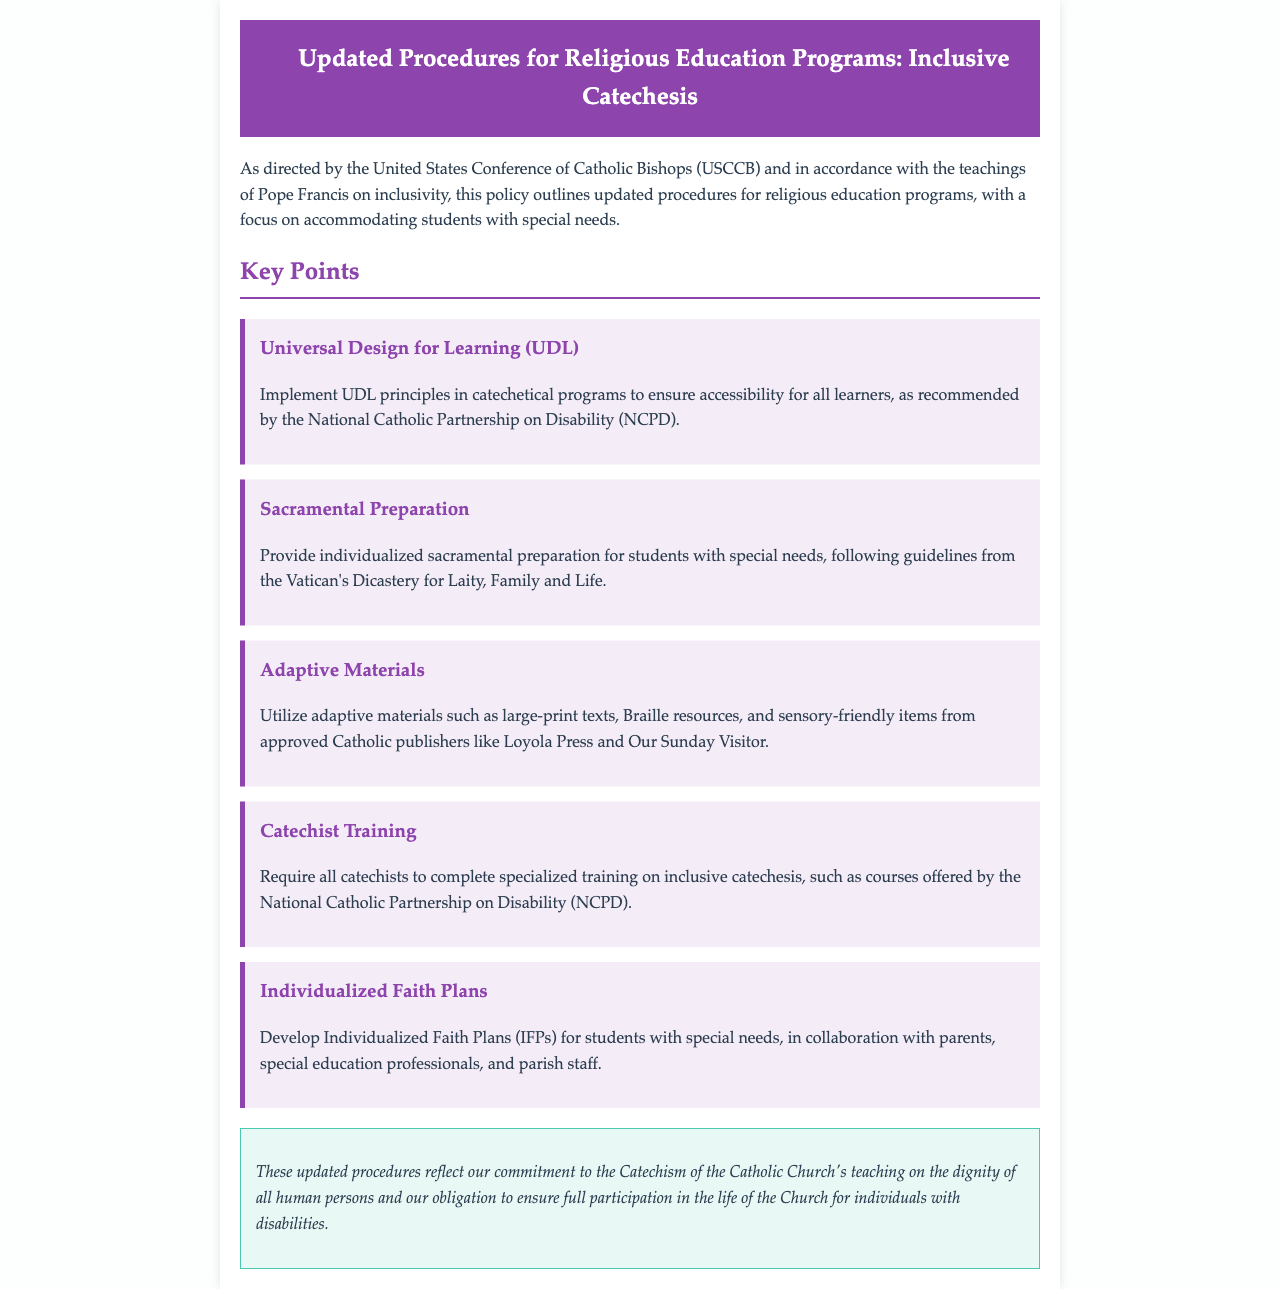What are the updated procedures focused on? The updated procedures are focused on accommodating students with special needs in religious education programs, as directed by the USCCB.
Answer: accommodating students with special needs What does UDL stand for? UDL stands for Universal Design for Learning, which is recommended for use in catechetical programs.
Answer: Universal Design for Learning Who requires specialized training on inclusive catechesis? All catechists are required to complete specialized training on inclusive catechesis.
Answer: All catechists What type of materials should be utilized for students with special needs? Adaptive materials such as large-print texts and Braille resources should be utilized.
Answer: Adaptive materials What are Individualized Faith Plans? Individualized Faith Plans (IFPs) are developed for students with special needs in collaboration with relevant stakeholders.
Answer: Individualized Faith Plans (IFPs) Which organization recommended the implementation of UDL principles? The National Catholic Partnership on Disability (NCPD) recommended the implementation of UDL principles.
Answer: National Catholic Partnership on Disability (NCPD) 